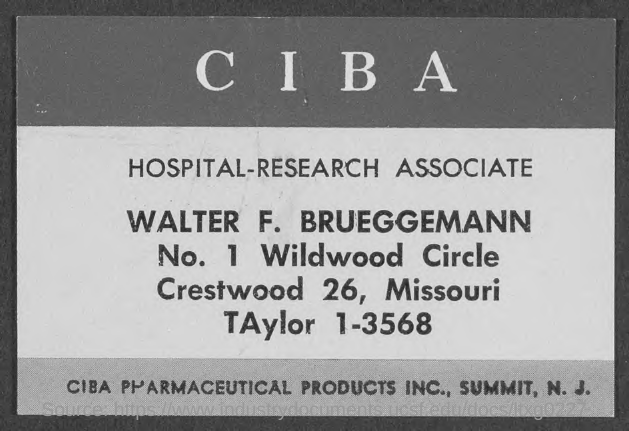Identify some key points in this picture. The individual listed in the document as the Hospital-Research Associate is Walter F. Brueggemann. 